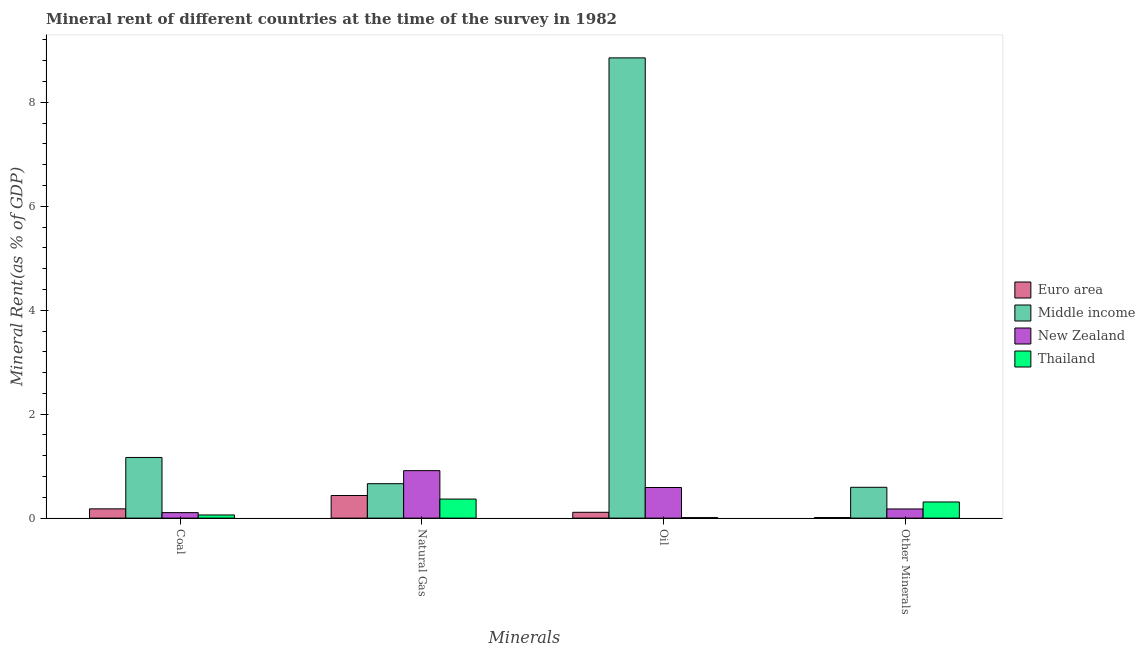How many different coloured bars are there?
Provide a succinct answer. 4. How many groups of bars are there?
Offer a very short reply. 4. How many bars are there on the 4th tick from the left?
Provide a short and direct response. 4. What is the label of the 3rd group of bars from the left?
Provide a short and direct response. Oil. What is the natural gas rent in New Zealand?
Give a very brief answer. 0.91. Across all countries, what is the maximum coal rent?
Give a very brief answer. 1.17. Across all countries, what is the minimum coal rent?
Your answer should be very brief. 0.06. In which country was the natural gas rent minimum?
Keep it short and to the point. Thailand. What is the total coal rent in the graph?
Your answer should be compact. 1.51. What is the difference between the  rent of other minerals in Middle income and that in Euro area?
Your answer should be compact. 0.58. What is the difference between the natural gas rent in Thailand and the  rent of other minerals in Euro area?
Your response must be concise. 0.36. What is the average coal rent per country?
Ensure brevity in your answer.  0.38. What is the difference between the coal rent and natural gas rent in Thailand?
Offer a terse response. -0.31. What is the ratio of the  rent of other minerals in New Zealand to that in Middle income?
Give a very brief answer. 0.3. Is the  rent of other minerals in Middle income less than that in Thailand?
Offer a terse response. No. Is the difference between the oil rent in New Zealand and Middle income greater than the difference between the  rent of other minerals in New Zealand and Middle income?
Ensure brevity in your answer.  No. What is the difference between the highest and the second highest natural gas rent?
Provide a short and direct response. 0.25. What is the difference between the highest and the lowest  rent of other minerals?
Make the answer very short. 0.58. In how many countries, is the  rent of other minerals greater than the average  rent of other minerals taken over all countries?
Your answer should be very brief. 2. Is the sum of the coal rent in Thailand and Euro area greater than the maximum natural gas rent across all countries?
Your answer should be compact. No. What does the 2nd bar from the left in Oil represents?
Give a very brief answer. Middle income. What does the 3rd bar from the right in Other Minerals represents?
Ensure brevity in your answer.  Middle income. Is it the case that in every country, the sum of the coal rent and natural gas rent is greater than the oil rent?
Make the answer very short. No. How many bars are there?
Offer a terse response. 16. Are all the bars in the graph horizontal?
Offer a very short reply. No. How many countries are there in the graph?
Offer a terse response. 4. What is the difference between two consecutive major ticks on the Y-axis?
Offer a terse response. 2. Are the values on the major ticks of Y-axis written in scientific E-notation?
Provide a short and direct response. No. Does the graph contain grids?
Make the answer very short. No. What is the title of the graph?
Your answer should be compact. Mineral rent of different countries at the time of the survey in 1982. What is the label or title of the X-axis?
Offer a terse response. Minerals. What is the label or title of the Y-axis?
Offer a terse response. Mineral Rent(as % of GDP). What is the Mineral Rent(as % of GDP) in Euro area in Coal?
Your answer should be compact. 0.18. What is the Mineral Rent(as % of GDP) in Middle income in Coal?
Make the answer very short. 1.17. What is the Mineral Rent(as % of GDP) of New Zealand in Coal?
Your answer should be very brief. 0.11. What is the Mineral Rent(as % of GDP) of Thailand in Coal?
Offer a very short reply. 0.06. What is the Mineral Rent(as % of GDP) in Euro area in Natural Gas?
Provide a short and direct response. 0.43. What is the Mineral Rent(as % of GDP) in Middle income in Natural Gas?
Keep it short and to the point. 0.66. What is the Mineral Rent(as % of GDP) in New Zealand in Natural Gas?
Offer a terse response. 0.91. What is the Mineral Rent(as % of GDP) in Thailand in Natural Gas?
Keep it short and to the point. 0.37. What is the Mineral Rent(as % of GDP) of Euro area in Oil?
Provide a succinct answer. 0.11. What is the Mineral Rent(as % of GDP) in Middle income in Oil?
Offer a very short reply. 8.86. What is the Mineral Rent(as % of GDP) in New Zealand in Oil?
Make the answer very short. 0.59. What is the Mineral Rent(as % of GDP) in Thailand in Oil?
Make the answer very short. 0.01. What is the Mineral Rent(as % of GDP) in Euro area in Other Minerals?
Offer a very short reply. 0.01. What is the Mineral Rent(as % of GDP) in Middle income in Other Minerals?
Ensure brevity in your answer.  0.59. What is the Mineral Rent(as % of GDP) of New Zealand in Other Minerals?
Your answer should be compact. 0.18. What is the Mineral Rent(as % of GDP) in Thailand in Other Minerals?
Provide a short and direct response. 0.31. Across all Minerals, what is the maximum Mineral Rent(as % of GDP) of Euro area?
Your response must be concise. 0.43. Across all Minerals, what is the maximum Mineral Rent(as % of GDP) of Middle income?
Offer a very short reply. 8.86. Across all Minerals, what is the maximum Mineral Rent(as % of GDP) of New Zealand?
Your answer should be compact. 0.91. Across all Minerals, what is the maximum Mineral Rent(as % of GDP) in Thailand?
Ensure brevity in your answer.  0.37. Across all Minerals, what is the minimum Mineral Rent(as % of GDP) in Euro area?
Provide a succinct answer. 0.01. Across all Minerals, what is the minimum Mineral Rent(as % of GDP) in Middle income?
Give a very brief answer. 0.59. Across all Minerals, what is the minimum Mineral Rent(as % of GDP) in New Zealand?
Give a very brief answer. 0.11. Across all Minerals, what is the minimum Mineral Rent(as % of GDP) in Thailand?
Provide a succinct answer. 0.01. What is the total Mineral Rent(as % of GDP) in Euro area in the graph?
Give a very brief answer. 0.74. What is the total Mineral Rent(as % of GDP) in Middle income in the graph?
Your answer should be very brief. 11.28. What is the total Mineral Rent(as % of GDP) in New Zealand in the graph?
Your response must be concise. 1.78. What is the total Mineral Rent(as % of GDP) in Thailand in the graph?
Provide a succinct answer. 0.75. What is the difference between the Mineral Rent(as % of GDP) of Euro area in Coal and that in Natural Gas?
Make the answer very short. -0.26. What is the difference between the Mineral Rent(as % of GDP) of Middle income in Coal and that in Natural Gas?
Your response must be concise. 0.51. What is the difference between the Mineral Rent(as % of GDP) in New Zealand in Coal and that in Natural Gas?
Your answer should be compact. -0.81. What is the difference between the Mineral Rent(as % of GDP) of Thailand in Coal and that in Natural Gas?
Keep it short and to the point. -0.31. What is the difference between the Mineral Rent(as % of GDP) in Euro area in Coal and that in Oil?
Your response must be concise. 0.07. What is the difference between the Mineral Rent(as % of GDP) in Middle income in Coal and that in Oil?
Your answer should be very brief. -7.69. What is the difference between the Mineral Rent(as % of GDP) in New Zealand in Coal and that in Oil?
Make the answer very short. -0.48. What is the difference between the Mineral Rent(as % of GDP) of Thailand in Coal and that in Oil?
Give a very brief answer. 0.05. What is the difference between the Mineral Rent(as % of GDP) of Euro area in Coal and that in Other Minerals?
Your answer should be compact. 0.17. What is the difference between the Mineral Rent(as % of GDP) of Middle income in Coal and that in Other Minerals?
Your response must be concise. 0.57. What is the difference between the Mineral Rent(as % of GDP) of New Zealand in Coal and that in Other Minerals?
Provide a short and direct response. -0.07. What is the difference between the Mineral Rent(as % of GDP) in Thailand in Coal and that in Other Minerals?
Make the answer very short. -0.25. What is the difference between the Mineral Rent(as % of GDP) of Euro area in Natural Gas and that in Oil?
Your response must be concise. 0.32. What is the difference between the Mineral Rent(as % of GDP) in Middle income in Natural Gas and that in Oil?
Your response must be concise. -8.19. What is the difference between the Mineral Rent(as % of GDP) in New Zealand in Natural Gas and that in Oil?
Provide a succinct answer. 0.32. What is the difference between the Mineral Rent(as % of GDP) of Thailand in Natural Gas and that in Oil?
Give a very brief answer. 0.36. What is the difference between the Mineral Rent(as % of GDP) of Euro area in Natural Gas and that in Other Minerals?
Keep it short and to the point. 0.42. What is the difference between the Mineral Rent(as % of GDP) in Middle income in Natural Gas and that in Other Minerals?
Give a very brief answer. 0.07. What is the difference between the Mineral Rent(as % of GDP) in New Zealand in Natural Gas and that in Other Minerals?
Give a very brief answer. 0.74. What is the difference between the Mineral Rent(as % of GDP) of Thailand in Natural Gas and that in Other Minerals?
Offer a terse response. 0.06. What is the difference between the Mineral Rent(as % of GDP) of Euro area in Oil and that in Other Minerals?
Make the answer very short. 0.1. What is the difference between the Mineral Rent(as % of GDP) of Middle income in Oil and that in Other Minerals?
Ensure brevity in your answer.  8.26. What is the difference between the Mineral Rent(as % of GDP) in New Zealand in Oil and that in Other Minerals?
Offer a terse response. 0.41. What is the difference between the Mineral Rent(as % of GDP) of Thailand in Oil and that in Other Minerals?
Give a very brief answer. -0.3. What is the difference between the Mineral Rent(as % of GDP) of Euro area in Coal and the Mineral Rent(as % of GDP) of Middle income in Natural Gas?
Provide a succinct answer. -0.48. What is the difference between the Mineral Rent(as % of GDP) of Euro area in Coal and the Mineral Rent(as % of GDP) of New Zealand in Natural Gas?
Offer a terse response. -0.73. What is the difference between the Mineral Rent(as % of GDP) in Euro area in Coal and the Mineral Rent(as % of GDP) in Thailand in Natural Gas?
Provide a short and direct response. -0.19. What is the difference between the Mineral Rent(as % of GDP) in Middle income in Coal and the Mineral Rent(as % of GDP) in New Zealand in Natural Gas?
Your answer should be compact. 0.25. What is the difference between the Mineral Rent(as % of GDP) of Middle income in Coal and the Mineral Rent(as % of GDP) of Thailand in Natural Gas?
Give a very brief answer. 0.8. What is the difference between the Mineral Rent(as % of GDP) in New Zealand in Coal and the Mineral Rent(as % of GDP) in Thailand in Natural Gas?
Provide a short and direct response. -0.26. What is the difference between the Mineral Rent(as % of GDP) of Euro area in Coal and the Mineral Rent(as % of GDP) of Middle income in Oil?
Ensure brevity in your answer.  -8.68. What is the difference between the Mineral Rent(as % of GDP) in Euro area in Coal and the Mineral Rent(as % of GDP) in New Zealand in Oil?
Your answer should be very brief. -0.41. What is the difference between the Mineral Rent(as % of GDP) of Euro area in Coal and the Mineral Rent(as % of GDP) of Thailand in Oil?
Provide a short and direct response. 0.17. What is the difference between the Mineral Rent(as % of GDP) in Middle income in Coal and the Mineral Rent(as % of GDP) in New Zealand in Oil?
Your response must be concise. 0.58. What is the difference between the Mineral Rent(as % of GDP) in Middle income in Coal and the Mineral Rent(as % of GDP) in Thailand in Oil?
Your answer should be compact. 1.16. What is the difference between the Mineral Rent(as % of GDP) of New Zealand in Coal and the Mineral Rent(as % of GDP) of Thailand in Oil?
Ensure brevity in your answer.  0.1. What is the difference between the Mineral Rent(as % of GDP) of Euro area in Coal and the Mineral Rent(as % of GDP) of Middle income in Other Minerals?
Make the answer very short. -0.41. What is the difference between the Mineral Rent(as % of GDP) in Euro area in Coal and the Mineral Rent(as % of GDP) in New Zealand in Other Minerals?
Offer a terse response. 0. What is the difference between the Mineral Rent(as % of GDP) in Euro area in Coal and the Mineral Rent(as % of GDP) in Thailand in Other Minerals?
Offer a very short reply. -0.13. What is the difference between the Mineral Rent(as % of GDP) in Middle income in Coal and the Mineral Rent(as % of GDP) in Thailand in Other Minerals?
Make the answer very short. 0.86. What is the difference between the Mineral Rent(as % of GDP) in New Zealand in Coal and the Mineral Rent(as % of GDP) in Thailand in Other Minerals?
Provide a short and direct response. -0.2. What is the difference between the Mineral Rent(as % of GDP) of Euro area in Natural Gas and the Mineral Rent(as % of GDP) of Middle income in Oil?
Give a very brief answer. -8.42. What is the difference between the Mineral Rent(as % of GDP) of Euro area in Natural Gas and the Mineral Rent(as % of GDP) of New Zealand in Oil?
Offer a terse response. -0.15. What is the difference between the Mineral Rent(as % of GDP) in Euro area in Natural Gas and the Mineral Rent(as % of GDP) in Thailand in Oil?
Your answer should be compact. 0.42. What is the difference between the Mineral Rent(as % of GDP) in Middle income in Natural Gas and the Mineral Rent(as % of GDP) in New Zealand in Oil?
Your answer should be compact. 0.07. What is the difference between the Mineral Rent(as % of GDP) in Middle income in Natural Gas and the Mineral Rent(as % of GDP) in Thailand in Oil?
Offer a terse response. 0.65. What is the difference between the Mineral Rent(as % of GDP) of New Zealand in Natural Gas and the Mineral Rent(as % of GDP) of Thailand in Oil?
Make the answer very short. 0.9. What is the difference between the Mineral Rent(as % of GDP) in Euro area in Natural Gas and the Mineral Rent(as % of GDP) in Middle income in Other Minerals?
Offer a terse response. -0.16. What is the difference between the Mineral Rent(as % of GDP) in Euro area in Natural Gas and the Mineral Rent(as % of GDP) in New Zealand in Other Minerals?
Ensure brevity in your answer.  0.26. What is the difference between the Mineral Rent(as % of GDP) in Euro area in Natural Gas and the Mineral Rent(as % of GDP) in Thailand in Other Minerals?
Give a very brief answer. 0.12. What is the difference between the Mineral Rent(as % of GDP) of Middle income in Natural Gas and the Mineral Rent(as % of GDP) of New Zealand in Other Minerals?
Ensure brevity in your answer.  0.49. What is the difference between the Mineral Rent(as % of GDP) in Middle income in Natural Gas and the Mineral Rent(as % of GDP) in Thailand in Other Minerals?
Your answer should be compact. 0.35. What is the difference between the Mineral Rent(as % of GDP) of New Zealand in Natural Gas and the Mineral Rent(as % of GDP) of Thailand in Other Minerals?
Ensure brevity in your answer.  0.6. What is the difference between the Mineral Rent(as % of GDP) of Euro area in Oil and the Mineral Rent(as % of GDP) of Middle income in Other Minerals?
Provide a short and direct response. -0.48. What is the difference between the Mineral Rent(as % of GDP) in Euro area in Oil and the Mineral Rent(as % of GDP) in New Zealand in Other Minerals?
Ensure brevity in your answer.  -0.06. What is the difference between the Mineral Rent(as % of GDP) in Euro area in Oil and the Mineral Rent(as % of GDP) in Thailand in Other Minerals?
Keep it short and to the point. -0.2. What is the difference between the Mineral Rent(as % of GDP) in Middle income in Oil and the Mineral Rent(as % of GDP) in New Zealand in Other Minerals?
Your response must be concise. 8.68. What is the difference between the Mineral Rent(as % of GDP) of Middle income in Oil and the Mineral Rent(as % of GDP) of Thailand in Other Minerals?
Offer a terse response. 8.54. What is the difference between the Mineral Rent(as % of GDP) of New Zealand in Oil and the Mineral Rent(as % of GDP) of Thailand in Other Minerals?
Provide a short and direct response. 0.28. What is the average Mineral Rent(as % of GDP) of Euro area per Minerals?
Your response must be concise. 0.18. What is the average Mineral Rent(as % of GDP) of Middle income per Minerals?
Make the answer very short. 2.82. What is the average Mineral Rent(as % of GDP) in New Zealand per Minerals?
Give a very brief answer. 0.45. What is the average Mineral Rent(as % of GDP) in Thailand per Minerals?
Provide a short and direct response. 0.19. What is the difference between the Mineral Rent(as % of GDP) in Euro area and Mineral Rent(as % of GDP) in Middle income in Coal?
Your answer should be very brief. -0.99. What is the difference between the Mineral Rent(as % of GDP) in Euro area and Mineral Rent(as % of GDP) in New Zealand in Coal?
Offer a very short reply. 0.07. What is the difference between the Mineral Rent(as % of GDP) of Euro area and Mineral Rent(as % of GDP) of Thailand in Coal?
Provide a succinct answer. 0.12. What is the difference between the Mineral Rent(as % of GDP) in Middle income and Mineral Rent(as % of GDP) in New Zealand in Coal?
Your response must be concise. 1.06. What is the difference between the Mineral Rent(as % of GDP) in Middle income and Mineral Rent(as % of GDP) in Thailand in Coal?
Make the answer very short. 1.11. What is the difference between the Mineral Rent(as % of GDP) of New Zealand and Mineral Rent(as % of GDP) of Thailand in Coal?
Keep it short and to the point. 0.04. What is the difference between the Mineral Rent(as % of GDP) of Euro area and Mineral Rent(as % of GDP) of Middle income in Natural Gas?
Make the answer very short. -0.23. What is the difference between the Mineral Rent(as % of GDP) of Euro area and Mineral Rent(as % of GDP) of New Zealand in Natural Gas?
Provide a short and direct response. -0.48. What is the difference between the Mineral Rent(as % of GDP) of Euro area and Mineral Rent(as % of GDP) of Thailand in Natural Gas?
Your answer should be very brief. 0.07. What is the difference between the Mineral Rent(as % of GDP) of Middle income and Mineral Rent(as % of GDP) of New Zealand in Natural Gas?
Keep it short and to the point. -0.25. What is the difference between the Mineral Rent(as % of GDP) in Middle income and Mineral Rent(as % of GDP) in Thailand in Natural Gas?
Offer a very short reply. 0.3. What is the difference between the Mineral Rent(as % of GDP) in New Zealand and Mineral Rent(as % of GDP) in Thailand in Natural Gas?
Offer a terse response. 0.55. What is the difference between the Mineral Rent(as % of GDP) in Euro area and Mineral Rent(as % of GDP) in Middle income in Oil?
Your answer should be compact. -8.74. What is the difference between the Mineral Rent(as % of GDP) of Euro area and Mineral Rent(as % of GDP) of New Zealand in Oil?
Your answer should be very brief. -0.48. What is the difference between the Mineral Rent(as % of GDP) of Euro area and Mineral Rent(as % of GDP) of Thailand in Oil?
Ensure brevity in your answer.  0.1. What is the difference between the Mineral Rent(as % of GDP) of Middle income and Mineral Rent(as % of GDP) of New Zealand in Oil?
Offer a very short reply. 8.27. What is the difference between the Mineral Rent(as % of GDP) of Middle income and Mineral Rent(as % of GDP) of Thailand in Oil?
Your response must be concise. 8.85. What is the difference between the Mineral Rent(as % of GDP) in New Zealand and Mineral Rent(as % of GDP) in Thailand in Oil?
Your answer should be compact. 0.58. What is the difference between the Mineral Rent(as % of GDP) of Euro area and Mineral Rent(as % of GDP) of Middle income in Other Minerals?
Your response must be concise. -0.58. What is the difference between the Mineral Rent(as % of GDP) of Euro area and Mineral Rent(as % of GDP) of New Zealand in Other Minerals?
Provide a succinct answer. -0.17. What is the difference between the Mineral Rent(as % of GDP) of Euro area and Mineral Rent(as % of GDP) of Thailand in Other Minerals?
Make the answer very short. -0.3. What is the difference between the Mineral Rent(as % of GDP) of Middle income and Mineral Rent(as % of GDP) of New Zealand in Other Minerals?
Offer a very short reply. 0.42. What is the difference between the Mineral Rent(as % of GDP) in Middle income and Mineral Rent(as % of GDP) in Thailand in Other Minerals?
Your answer should be compact. 0.28. What is the difference between the Mineral Rent(as % of GDP) of New Zealand and Mineral Rent(as % of GDP) of Thailand in Other Minerals?
Give a very brief answer. -0.13. What is the ratio of the Mineral Rent(as % of GDP) of Euro area in Coal to that in Natural Gas?
Make the answer very short. 0.41. What is the ratio of the Mineral Rent(as % of GDP) in Middle income in Coal to that in Natural Gas?
Provide a succinct answer. 1.76. What is the ratio of the Mineral Rent(as % of GDP) in New Zealand in Coal to that in Natural Gas?
Provide a succinct answer. 0.12. What is the ratio of the Mineral Rent(as % of GDP) in Thailand in Coal to that in Natural Gas?
Ensure brevity in your answer.  0.17. What is the ratio of the Mineral Rent(as % of GDP) of Euro area in Coal to that in Oil?
Provide a succinct answer. 1.59. What is the ratio of the Mineral Rent(as % of GDP) of Middle income in Coal to that in Oil?
Provide a succinct answer. 0.13. What is the ratio of the Mineral Rent(as % of GDP) in New Zealand in Coal to that in Oil?
Ensure brevity in your answer.  0.18. What is the ratio of the Mineral Rent(as % of GDP) of Thailand in Coal to that in Oil?
Offer a terse response. 6.05. What is the ratio of the Mineral Rent(as % of GDP) of Euro area in Coal to that in Other Minerals?
Offer a terse response. 16.04. What is the ratio of the Mineral Rent(as % of GDP) of Middle income in Coal to that in Other Minerals?
Ensure brevity in your answer.  1.97. What is the ratio of the Mineral Rent(as % of GDP) in New Zealand in Coal to that in Other Minerals?
Keep it short and to the point. 0.6. What is the ratio of the Mineral Rent(as % of GDP) in Thailand in Coal to that in Other Minerals?
Provide a succinct answer. 0.2. What is the ratio of the Mineral Rent(as % of GDP) in Euro area in Natural Gas to that in Oil?
Provide a succinct answer. 3.88. What is the ratio of the Mineral Rent(as % of GDP) of Middle income in Natural Gas to that in Oil?
Your answer should be very brief. 0.07. What is the ratio of the Mineral Rent(as % of GDP) of New Zealand in Natural Gas to that in Oil?
Keep it short and to the point. 1.55. What is the ratio of the Mineral Rent(as % of GDP) of Thailand in Natural Gas to that in Oil?
Offer a very short reply. 36.61. What is the ratio of the Mineral Rent(as % of GDP) of Euro area in Natural Gas to that in Other Minerals?
Offer a very short reply. 39.1. What is the ratio of the Mineral Rent(as % of GDP) in Middle income in Natural Gas to that in Other Minerals?
Your response must be concise. 1.12. What is the ratio of the Mineral Rent(as % of GDP) of New Zealand in Natural Gas to that in Other Minerals?
Offer a very short reply. 5.18. What is the ratio of the Mineral Rent(as % of GDP) of Thailand in Natural Gas to that in Other Minerals?
Your response must be concise. 1.18. What is the ratio of the Mineral Rent(as % of GDP) in Euro area in Oil to that in Other Minerals?
Give a very brief answer. 10.09. What is the ratio of the Mineral Rent(as % of GDP) in Middle income in Oil to that in Other Minerals?
Your answer should be very brief. 14.93. What is the ratio of the Mineral Rent(as % of GDP) of New Zealand in Oil to that in Other Minerals?
Your answer should be compact. 3.34. What is the ratio of the Mineral Rent(as % of GDP) of Thailand in Oil to that in Other Minerals?
Provide a succinct answer. 0.03. What is the difference between the highest and the second highest Mineral Rent(as % of GDP) in Euro area?
Provide a succinct answer. 0.26. What is the difference between the highest and the second highest Mineral Rent(as % of GDP) of Middle income?
Your answer should be very brief. 7.69. What is the difference between the highest and the second highest Mineral Rent(as % of GDP) of New Zealand?
Provide a succinct answer. 0.32. What is the difference between the highest and the second highest Mineral Rent(as % of GDP) in Thailand?
Offer a terse response. 0.06. What is the difference between the highest and the lowest Mineral Rent(as % of GDP) of Euro area?
Keep it short and to the point. 0.42. What is the difference between the highest and the lowest Mineral Rent(as % of GDP) in Middle income?
Your answer should be very brief. 8.26. What is the difference between the highest and the lowest Mineral Rent(as % of GDP) in New Zealand?
Your answer should be compact. 0.81. What is the difference between the highest and the lowest Mineral Rent(as % of GDP) in Thailand?
Ensure brevity in your answer.  0.36. 